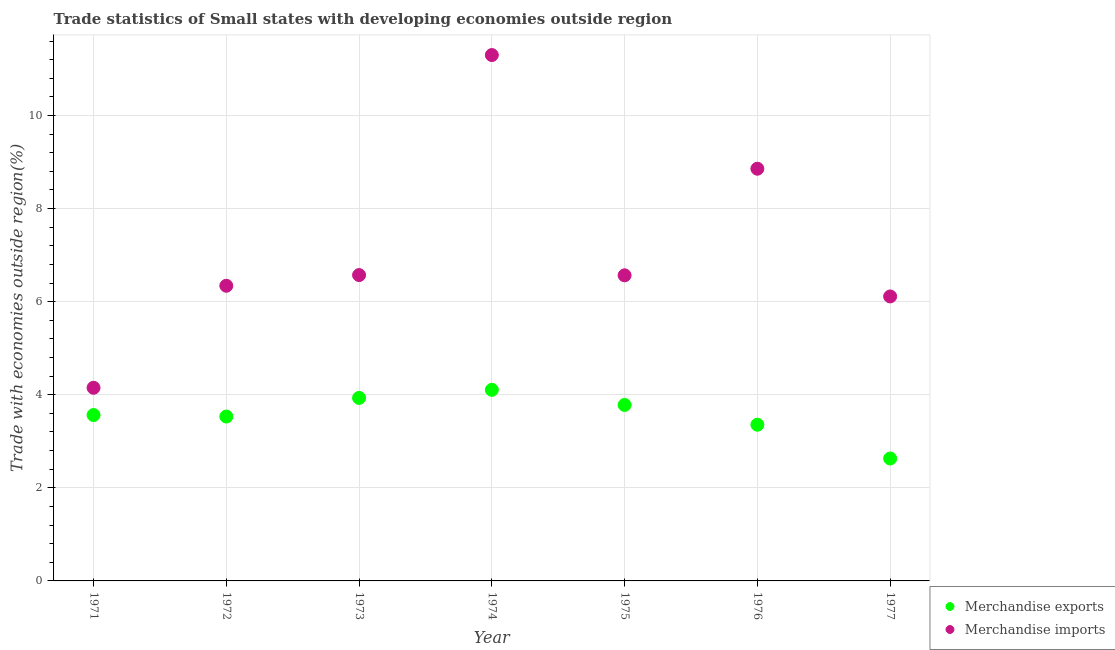Is the number of dotlines equal to the number of legend labels?
Ensure brevity in your answer.  Yes. What is the merchandise exports in 1973?
Offer a terse response. 3.93. Across all years, what is the maximum merchandise imports?
Make the answer very short. 11.3. Across all years, what is the minimum merchandise imports?
Provide a succinct answer. 4.15. In which year was the merchandise exports maximum?
Make the answer very short. 1974. In which year was the merchandise exports minimum?
Provide a succinct answer. 1977. What is the total merchandise imports in the graph?
Your answer should be compact. 49.9. What is the difference between the merchandise imports in 1974 and that in 1975?
Make the answer very short. 4.73. What is the difference between the merchandise imports in 1974 and the merchandise exports in 1976?
Offer a terse response. 7.94. What is the average merchandise exports per year?
Provide a short and direct response. 3.56. In the year 1972, what is the difference between the merchandise exports and merchandise imports?
Offer a very short reply. -2.81. In how many years, is the merchandise imports greater than 8 %?
Offer a very short reply. 2. What is the ratio of the merchandise exports in 1972 to that in 1974?
Provide a short and direct response. 0.86. What is the difference between the highest and the second highest merchandise exports?
Provide a succinct answer. 0.17. What is the difference between the highest and the lowest merchandise imports?
Provide a short and direct response. 7.15. Does the merchandise imports monotonically increase over the years?
Your answer should be compact. No. How many years are there in the graph?
Provide a succinct answer. 7. What is the difference between two consecutive major ticks on the Y-axis?
Offer a terse response. 2. Are the values on the major ticks of Y-axis written in scientific E-notation?
Make the answer very short. No. Does the graph contain grids?
Offer a very short reply. Yes. How are the legend labels stacked?
Provide a short and direct response. Vertical. What is the title of the graph?
Your answer should be very brief. Trade statistics of Small states with developing economies outside region. Does "Banks" appear as one of the legend labels in the graph?
Make the answer very short. No. What is the label or title of the X-axis?
Ensure brevity in your answer.  Year. What is the label or title of the Y-axis?
Give a very brief answer. Trade with economies outside region(%). What is the Trade with economies outside region(%) in Merchandise exports in 1971?
Provide a succinct answer. 3.56. What is the Trade with economies outside region(%) of Merchandise imports in 1971?
Make the answer very short. 4.15. What is the Trade with economies outside region(%) in Merchandise exports in 1972?
Provide a succinct answer. 3.53. What is the Trade with economies outside region(%) of Merchandise imports in 1972?
Your answer should be very brief. 6.34. What is the Trade with economies outside region(%) in Merchandise exports in 1973?
Your answer should be very brief. 3.93. What is the Trade with economies outside region(%) of Merchandise imports in 1973?
Make the answer very short. 6.57. What is the Trade with economies outside region(%) of Merchandise exports in 1974?
Provide a succinct answer. 4.11. What is the Trade with economies outside region(%) of Merchandise imports in 1974?
Provide a succinct answer. 11.3. What is the Trade with economies outside region(%) in Merchandise exports in 1975?
Your answer should be very brief. 3.78. What is the Trade with economies outside region(%) of Merchandise imports in 1975?
Give a very brief answer. 6.57. What is the Trade with economies outside region(%) in Merchandise exports in 1976?
Your answer should be compact. 3.36. What is the Trade with economies outside region(%) of Merchandise imports in 1976?
Offer a terse response. 8.86. What is the Trade with economies outside region(%) of Merchandise exports in 1977?
Your answer should be compact. 2.63. What is the Trade with economies outside region(%) of Merchandise imports in 1977?
Offer a terse response. 6.11. Across all years, what is the maximum Trade with economies outside region(%) of Merchandise exports?
Offer a terse response. 4.11. Across all years, what is the maximum Trade with economies outside region(%) of Merchandise imports?
Ensure brevity in your answer.  11.3. Across all years, what is the minimum Trade with economies outside region(%) in Merchandise exports?
Make the answer very short. 2.63. Across all years, what is the minimum Trade with economies outside region(%) of Merchandise imports?
Make the answer very short. 4.15. What is the total Trade with economies outside region(%) of Merchandise exports in the graph?
Your response must be concise. 24.9. What is the total Trade with economies outside region(%) of Merchandise imports in the graph?
Ensure brevity in your answer.  49.9. What is the difference between the Trade with economies outside region(%) of Merchandise exports in 1971 and that in 1972?
Keep it short and to the point. 0.03. What is the difference between the Trade with economies outside region(%) in Merchandise imports in 1971 and that in 1972?
Your answer should be compact. -2.19. What is the difference between the Trade with economies outside region(%) of Merchandise exports in 1971 and that in 1973?
Keep it short and to the point. -0.37. What is the difference between the Trade with economies outside region(%) in Merchandise imports in 1971 and that in 1973?
Your answer should be very brief. -2.42. What is the difference between the Trade with economies outside region(%) of Merchandise exports in 1971 and that in 1974?
Your response must be concise. -0.54. What is the difference between the Trade with economies outside region(%) in Merchandise imports in 1971 and that in 1974?
Your answer should be compact. -7.15. What is the difference between the Trade with economies outside region(%) in Merchandise exports in 1971 and that in 1975?
Offer a very short reply. -0.22. What is the difference between the Trade with economies outside region(%) of Merchandise imports in 1971 and that in 1975?
Your answer should be very brief. -2.42. What is the difference between the Trade with economies outside region(%) in Merchandise exports in 1971 and that in 1976?
Give a very brief answer. 0.21. What is the difference between the Trade with economies outside region(%) of Merchandise imports in 1971 and that in 1976?
Offer a terse response. -4.71. What is the difference between the Trade with economies outside region(%) of Merchandise exports in 1971 and that in 1977?
Offer a terse response. 0.93. What is the difference between the Trade with economies outside region(%) in Merchandise imports in 1971 and that in 1977?
Your answer should be compact. -1.96. What is the difference between the Trade with economies outside region(%) in Merchandise exports in 1972 and that in 1973?
Provide a short and direct response. -0.4. What is the difference between the Trade with economies outside region(%) in Merchandise imports in 1972 and that in 1973?
Provide a short and direct response. -0.23. What is the difference between the Trade with economies outside region(%) in Merchandise exports in 1972 and that in 1974?
Give a very brief answer. -0.57. What is the difference between the Trade with economies outside region(%) in Merchandise imports in 1972 and that in 1974?
Your response must be concise. -4.96. What is the difference between the Trade with economies outside region(%) of Merchandise exports in 1972 and that in 1975?
Ensure brevity in your answer.  -0.25. What is the difference between the Trade with economies outside region(%) in Merchandise imports in 1972 and that in 1975?
Make the answer very short. -0.22. What is the difference between the Trade with economies outside region(%) of Merchandise exports in 1972 and that in 1976?
Keep it short and to the point. 0.18. What is the difference between the Trade with economies outside region(%) in Merchandise imports in 1972 and that in 1976?
Keep it short and to the point. -2.51. What is the difference between the Trade with economies outside region(%) of Merchandise exports in 1972 and that in 1977?
Provide a short and direct response. 0.9. What is the difference between the Trade with economies outside region(%) in Merchandise imports in 1972 and that in 1977?
Keep it short and to the point. 0.23. What is the difference between the Trade with economies outside region(%) of Merchandise exports in 1973 and that in 1974?
Give a very brief answer. -0.17. What is the difference between the Trade with economies outside region(%) of Merchandise imports in 1973 and that in 1974?
Your answer should be compact. -4.73. What is the difference between the Trade with economies outside region(%) of Merchandise exports in 1973 and that in 1975?
Offer a very short reply. 0.15. What is the difference between the Trade with economies outside region(%) in Merchandise imports in 1973 and that in 1975?
Make the answer very short. 0.01. What is the difference between the Trade with economies outside region(%) of Merchandise exports in 1973 and that in 1976?
Provide a succinct answer. 0.58. What is the difference between the Trade with economies outside region(%) of Merchandise imports in 1973 and that in 1976?
Offer a very short reply. -2.29. What is the difference between the Trade with economies outside region(%) in Merchandise exports in 1973 and that in 1977?
Make the answer very short. 1.3. What is the difference between the Trade with economies outside region(%) of Merchandise imports in 1973 and that in 1977?
Your answer should be very brief. 0.46. What is the difference between the Trade with economies outside region(%) of Merchandise exports in 1974 and that in 1975?
Ensure brevity in your answer.  0.33. What is the difference between the Trade with economies outside region(%) in Merchandise imports in 1974 and that in 1975?
Offer a terse response. 4.73. What is the difference between the Trade with economies outside region(%) of Merchandise exports in 1974 and that in 1976?
Ensure brevity in your answer.  0.75. What is the difference between the Trade with economies outside region(%) in Merchandise imports in 1974 and that in 1976?
Offer a very short reply. 2.44. What is the difference between the Trade with economies outside region(%) in Merchandise exports in 1974 and that in 1977?
Offer a terse response. 1.48. What is the difference between the Trade with economies outside region(%) in Merchandise imports in 1974 and that in 1977?
Provide a succinct answer. 5.19. What is the difference between the Trade with economies outside region(%) of Merchandise exports in 1975 and that in 1976?
Your answer should be compact. 0.42. What is the difference between the Trade with economies outside region(%) of Merchandise imports in 1975 and that in 1976?
Keep it short and to the point. -2.29. What is the difference between the Trade with economies outside region(%) of Merchandise exports in 1975 and that in 1977?
Keep it short and to the point. 1.15. What is the difference between the Trade with economies outside region(%) of Merchandise imports in 1975 and that in 1977?
Your response must be concise. 0.45. What is the difference between the Trade with economies outside region(%) of Merchandise exports in 1976 and that in 1977?
Keep it short and to the point. 0.73. What is the difference between the Trade with economies outside region(%) in Merchandise imports in 1976 and that in 1977?
Keep it short and to the point. 2.74. What is the difference between the Trade with economies outside region(%) of Merchandise exports in 1971 and the Trade with economies outside region(%) of Merchandise imports in 1972?
Your answer should be very brief. -2.78. What is the difference between the Trade with economies outside region(%) in Merchandise exports in 1971 and the Trade with economies outside region(%) in Merchandise imports in 1973?
Give a very brief answer. -3.01. What is the difference between the Trade with economies outside region(%) of Merchandise exports in 1971 and the Trade with economies outside region(%) of Merchandise imports in 1974?
Offer a terse response. -7.74. What is the difference between the Trade with economies outside region(%) of Merchandise exports in 1971 and the Trade with economies outside region(%) of Merchandise imports in 1975?
Your answer should be compact. -3. What is the difference between the Trade with economies outside region(%) of Merchandise exports in 1971 and the Trade with economies outside region(%) of Merchandise imports in 1976?
Your answer should be very brief. -5.29. What is the difference between the Trade with economies outside region(%) in Merchandise exports in 1971 and the Trade with economies outside region(%) in Merchandise imports in 1977?
Offer a terse response. -2.55. What is the difference between the Trade with economies outside region(%) in Merchandise exports in 1972 and the Trade with economies outside region(%) in Merchandise imports in 1973?
Your answer should be compact. -3.04. What is the difference between the Trade with economies outside region(%) of Merchandise exports in 1972 and the Trade with economies outside region(%) of Merchandise imports in 1974?
Ensure brevity in your answer.  -7.77. What is the difference between the Trade with economies outside region(%) in Merchandise exports in 1972 and the Trade with economies outside region(%) in Merchandise imports in 1975?
Offer a terse response. -3.03. What is the difference between the Trade with economies outside region(%) of Merchandise exports in 1972 and the Trade with economies outside region(%) of Merchandise imports in 1976?
Keep it short and to the point. -5.32. What is the difference between the Trade with economies outside region(%) in Merchandise exports in 1972 and the Trade with economies outside region(%) in Merchandise imports in 1977?
Ensure brevity in your answer.  -2.58. What is the difference between the Trade with economies outside region(%) of Merchandise exports in 1973 and the Trade with economies outside region(%) of Merchandise imports in 1974?
Offer a very short reply. -7.37. What is the difference between the Trade with economies outside region(%) of Merchandise exports in 1973 and the Trade with economies outside region(%) of Merchandise imports in 1975?
Your answer should be very brief. -2.63. What is the difference between the Trade with economies outside region(%) in Merchandise exports in 1973 and the Trade with economies outside region(%) in Merchandise imports in 1976?
Ensure brevity in your answer.  -4.92. What is the difference between the Trade with economies outside region(%) of Merchandise exports in 1973 and the Trade with economies outside region(%) of Merchandise imports in 1977?
Make the answer very short. -2.18. What is the difference between the Trade with economies outside region(%) of Merchandise exports in 1974 and the Trade with economies outside region(%) of Merchandise imports in 1975?
Make the answer very short. -2.46. What is the difference between the Trade with economies outside region(%) in Merchandise exports in 1974 and the Trade with economies outside region(%) in Merchandise imports in 1976?
Give a very brief answer. -4.75. What is the difference between the Trade with economies outside region(%) of Merchandise exports in 1974 and the Trade with economies outside region(%) of Merchandise imports in 1977?
Provide a succinct answer. -2.01. What is the difference between the Trade with economies outside region(%) of Merchandise exports in 1975 and the Trade with economies outside region(%) of Merchandise imports in 1976?
Provide a succinct answer. -5.08. What is the difference between the Trade with economies outside region(%) of Merchandise exports in 1975 and the Trade with economies outside region(%) of Merchandise imports in 1977?
Offer a terse response. -2.33. What is the difference between the Trade with economies outside region(%) in Merchandise exports in 1976 and the Trade with economies outside region(%) in Merchandise imports in 1977?
Provide a short and direct response. -2.76. What is the average Trade with economies outside region(%) in Merchandise exports per year?
Offer a very short reply. 3.56. What is the average Trade with economies outside region(%) in Merchandise imports per year?
Offer a very short reply. 7.13. In the year 1971, what is the difference between the Trade with economies outside region(%) in Merchandise exports and Trade with economies outside region(%) in Merchandise imports?
Your answer should be very brief. -0.59. In the year 1972, what is the difference between the Trade with economies outside region(%) in Merchandise exports and Trade with economies outside region(%) in Merchandise imports?
Make the answer very short. -2.81. In the year 1973, what is the difference between the Trade with economies outside region(%) of Merchandise exports and Trade with economies outside region(%) of Merchandise imports?
Provide a succinct answer. -2.64. In the year 1974, what is the difference between the Trade with economies outside region(%) in Merchandise exports and Trade with economies outside region(%) in Merchandise imports?
Keep it short and to the point. -7.19. In the year 1975, what is the difference between the Trade with economies outside region(%) in Merchandise exports and Trade with economies outside region(%) in Merchandise imports?
Provide a short and direct response. -2.79. In the year 1976, what is the difference between the Trade with economies outside region(%) of Merchandise exports and Trade with economies outside region(%) of Merchandise imports?
Your answer should be compact. -5.5. In the year 1977, what is the difference between the Trade with economies outside region(%) in Merchandise exports and Trade with economies outside region(%) in Merchandise imports?
Keep it short and to the point. -3.48. What is the ratio of the Trade with economies outside region(%) in Merchandise exports in 1971 to that in 1972?
Offer a terse response. 1.01. What is the ratio of the Trade with economies outside region(%) in Merchandise imports in 1971 to that in 1972?
Make the answer very short. 0.65. What is the ratio of the Trade with economies outside region(%) in Merchandise exports in 1971 to that in 1973?
Offer a terse response. 0.91. What is the ratio of the Trade with economies outside region(%) in Merchandise imports in 1971 to that in 1973?
Provide a succinct answer. 0.63. What is the ratio of the Trade with economies outside region(%) of Merchandise exports in 1971 to that in 1974?
Provide a succinct answer. 0.87. What is the ratio of the Trade with economies outside region(%) of Merchandise imports in 1971 to that in 1974?
Give a very brief answer. 0.37. What is the ratio of the Trade with economies outside region(%) of Merchandise exports in 1971 to that in 1975?
Your answer should be compact. 0.94. What is the ratio of the Trade with economies outside region(%) of Merchandise imports in 1971 to that in 1975?
Your response must be concise. 0.63. What is the ratio of the Trade with economies outside region(%) in Merchandise exports in 1971 to that in 1976?
Ensure brevity in your answer.  1.06. What is the ratio of the Trade with economies outside region(%) of Merchandise imports in 1971 to that in 1976?
Keep it short and to the point. 0.47. What is the ratio of the Trade with economies outside region(%) of Merchandise exports in 1971 to that in 1977?
Your response must be concise. 1.35. What is the ratio of the Trade with economies outside region(%) in Merchandise imports in 1971 to that in 1977?
Your answer should be compact. 0.68. What is the ratio of the Trade with economies outside region(%) of Merchandise exports in 1972 to that in 1973?
Your answer should be very brief. 0.9. What is the ratio of the Trade with economies outside region(%) in Merchandise imports in 1972 to that in 1973?
Your answer should be very brief. 0.97. What is the ratio of the Trade with economies outside region(%) of Merchandise exports in 1972 to that in 1974?
Ensure brevity in your answer.  0.86. What is the ratio of the Trade with economies outside region(%) of Merchandise imports in 1972 to that in 1974?
Provide a succinct answer. 0.56. What is the ratio of the Trade with economies outside region(%) in Merchandise exports in 1972 to that in 1975?
Provide a short and direct response. 0.93. What is the ratio of the Trade with economies outside region(%) in Merchandise imports in 1972 to that in 1975?
Your response must be concise. 0.97. What is the ratio of the Trade with economies outside region(%) of Merchandise exports in 1972 to that in 1976?
Ensure brevity in your answer.  1.05. What is the ratio of the Trade with economies outside region(%) of Merchandise imports in 1972 to that in 1976?
Give a very brief answer. 0.72. What is the ratio of the Trade with economies outside region(%) in Merchandise exports in 1972 to that in 1977?
Offer a terse response. 1.34. What is the ratio of the Trade with economies outside region(%) of Merchandise imports in 1972 to that in 1977?
Provide a short and direct response. 1.04. What is the ratio of the Trade with economies outside region(%) of Merchandise exports in 1973 to that in 1974?
Your response must be concise. 0.96. What is the ratio of the Trade with economies outside region(%) of Merchandise imports in 1973 to that in 1974?
Provide a succinct answer. 0.58. What is the ratio of the Trade with economies outside region(%) of Merchandise imports in 1973 to that in 1975?
Your answer should be very brief. 1. What is the ratio of the Trade with economies outside region(%) in Merchandise exports in 1973 to that in 1976?
Ensure brevity in your answer.  1.17. What is the ratio of the Trade with economies outside region(%) in Merchandise imports in 1973 to that in 1976?
Provide a succinct answer. 0.74. What is the ratio of the Trade with economies outside region(%) in Merchandise exports in 1973 to that in 1977?
Give a very brief answer. 1.49. What is the ratio of the Trade with economies outside region(%) in Merchandise imports in 1973 to that in 1977?
Provide a short and direct response. 1.08. What is the ratio of the Trade with economies outside region(%) of Merchandise exports in 1974 to that in 1975?
Offer a very short reply. 1.09. What is the ratio of the Trade with economies outside region(%) of Merchandise imports in 1974 to that in 1975?
Your answer should be compact. 1.72. What is the ratio of the Trade with economies outside region(%) in Merchandise exports in 1974 to that in 1976?
Make the answer very short. 1.22. What is the ratio of the Trade with economies outside region(%) of Merchandise imports in 1974 to that in 1976?
Give a very brief answer. 1.28. What is the ratio of the Trade with economies outside region(%) of Merchandise exports in 1974 to that in 1977?
Your answer should be very brief. 1.56. What is the ratio of the Trade with economies outside region(%) of Merchandise imports in 1974 to that in 1977?
Provide a short and direct response. 1.85. What is the ratio of the Trade with economies outside region(%) of Merchandise exports in 1975 to that in 1976?
Provide a succinct answer. 1.13. What is the ratio of the Trade with economies outside region(%) in Merchandise imports in 1975 to that in 1976?
Make the answer very short. 0.74. What is the ratio of the Trade with economies outside region(%) of Merchandise exports in 1975 to that in 1977?
Offer a very short reply. 1.44. What is the ratio of the Trade with economies outside region(%) in Merchandise imports in 1975 to that in 1977?
Provide a succinct answer. 1.07. What is the ratio of the Trade with economies outside region(%) of Merchandise exports in 1976 to that in 1977?
Provide a short and direct response. 1.28. What is the ratio of the Trade with economies outside region(%) in Merchandise imports in 1976 to that in 1977?
Make the answer very short. 1.45. What is the difference between the highest and the second highest Trade with economies outside region(%) in Merchandise exports?
Offer a terse response. 0.17. What is the difference between the highest and the second highest Trade with economies outside region(%) of Merchandise imports?
Make the answer very short. 2.44. What is the difference between the highest and the lowest Trade with economies outside region(%) in Merchandise exports?
Give a very brief answer. 1.48. What is the difference between the highest and the lowest Trade with economies outside region(%) in Merchandise imports?
Make the answer very short. 7.15. 